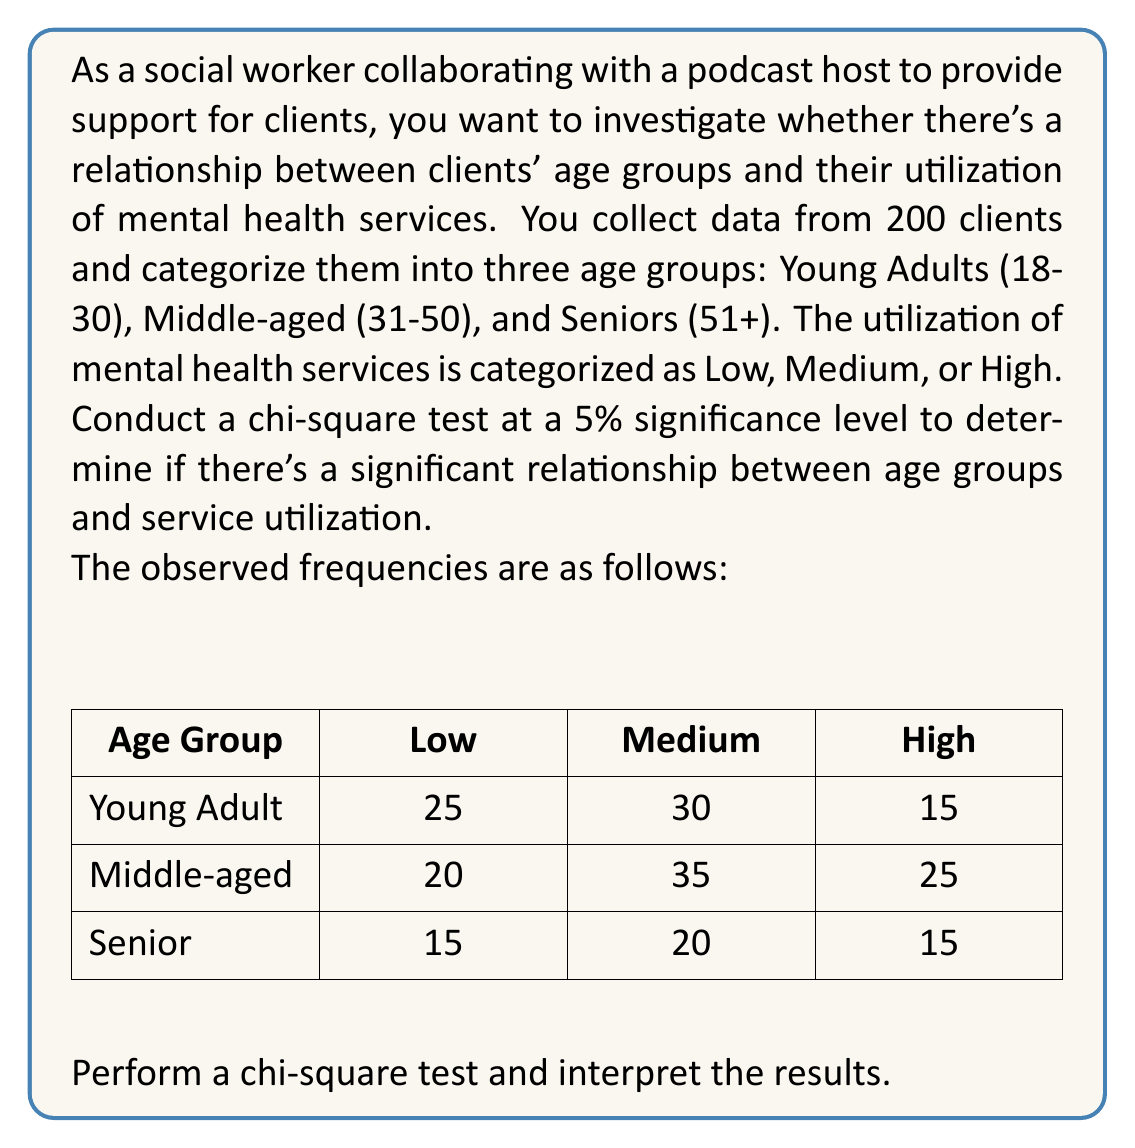Could you help me with this problem? To perform a chi-square test, we'll follow these steps:

1. State the hypotheses:
   $H_0$: There is no relationship between age groups and service utilization.
   $H_1$: There is a relationship between age groups and service utilization.

2. Calculate the expected frequencies:
   For each cell, Expected Frequency = (Row Total × Column Total) / Grand Total

   Young Adult, Low: $E = (70 × 60) / 200 = 21$
   Young Adult, Medium: $E = (70 × 85) / 200 = 29.75$
   Young Adult, High: $E = (70 × 55) / 200 = 19.25$
   Middle-aged, Low: $E = (80 × 60) / 200 = 24$
   Middle-aged, Medium: $E = (80 × 85) / 200 = 34$
   Middle-aged, High: $E = (80 × 55) / 200 = 22$
   Senior, Low: $E = (50 × 60) / 200 = 15$
   Senior, Medium: $E = (50 × 85) / 200 = 21.25$
   Senior, High: $E = (50 × 55) / 200 = 13.75$

3. Calculate the chi-square statistic:
   $$\chi^2 = \sum \frac{(O - E)^2}{E}$$

   Where O is the observed frequency and E is the expected frequency.

   $$\chi^2 = \frac{(25 - 21)^2}{21} + \frac{(30 - 29.75)^2}{29.75} + \frac{(15 - 19.25)^2}{19.25} + \cdots + \frac{(15 - 13.75)^2}{13.75}$$

   $$\chi^2 \approx 5.7276$$

4. Determine the degrees of freedom:
   df = (rows - 1) × (columns - 1) = (3 - 1) × (3 - 1) = 4

5. Find the critical value:
   At a 5% significance level with 4 degrees of freedom, the critical value is 9.488.

6. Compare the chi-square statistic to the critical value:
   Since $5.7276 < 9.488$, we fail to reject the null hypothesis.

7. Calculate the p-value:
   Using a chi-square distribution calculator, we find that the p-value is approximately 0.2204.

8. Interpret the results:
   Since the p-value (0.2204) is greater than the significance level (0.05), we fail to reject the null hypothesis. There is not enough evidence to conclude that there is a significant relationship between age groups and mental health service utilization.
Answer: Fail to reject the null hypothesis. There is not enough evidence to conclude that there is a significant relationship between age groups and mental health service utilization (χ² = 5.7276, df = 4, p = 0.2204). 